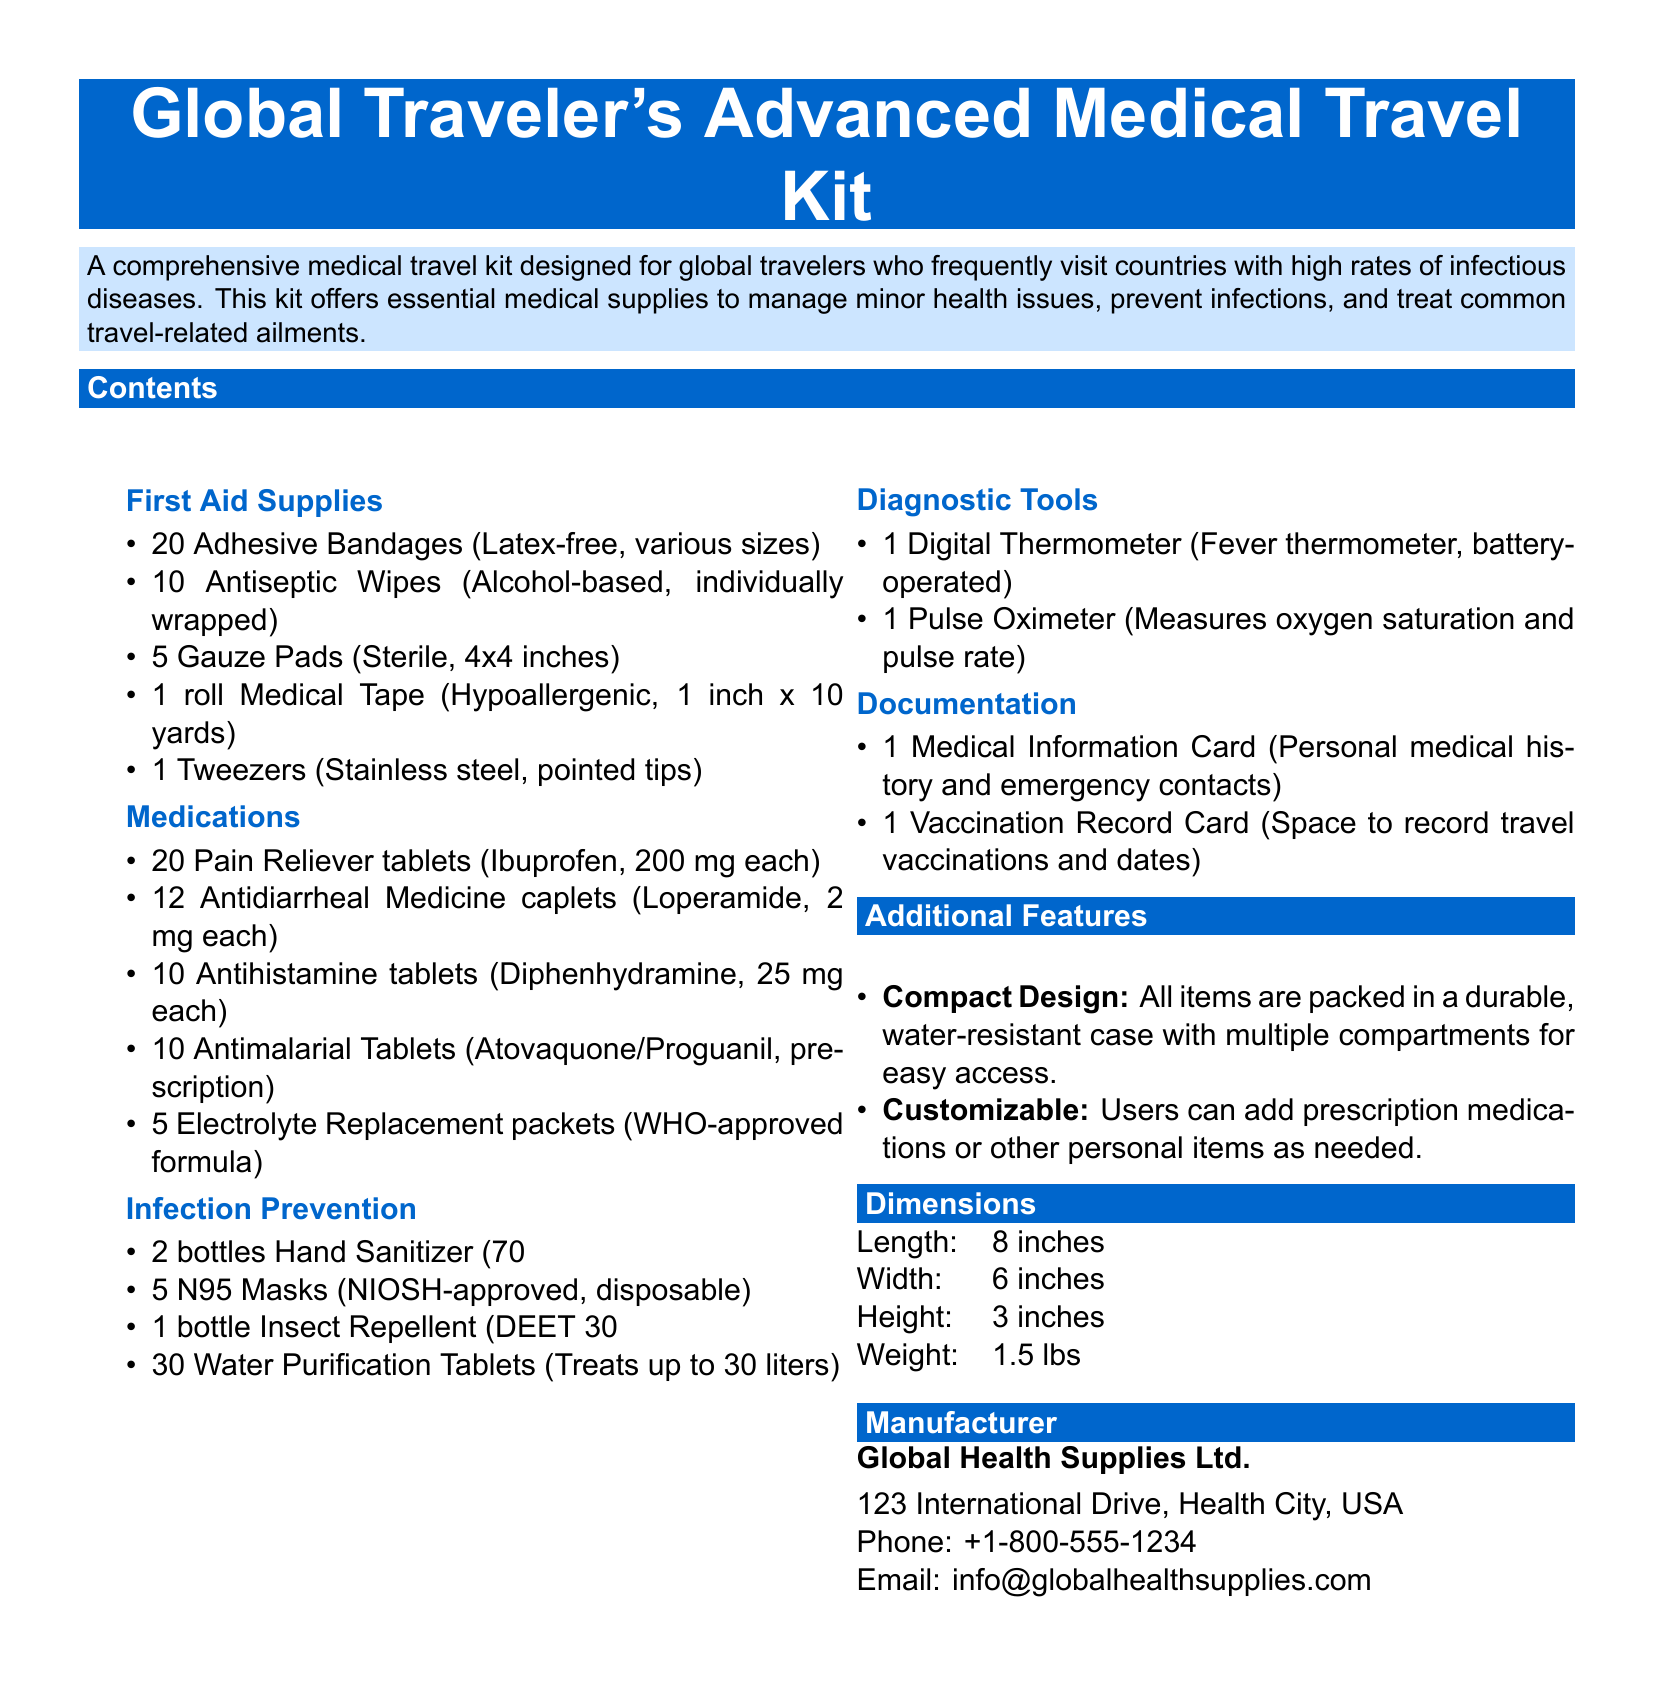What is the weight of the medical travel kit? The weight of the medical travel kit is specified in the dimensions section of the document.
Answer: 1.5 lbs How many Adhesive Bandages are included? The number of Adhesive Bandages is listed under the First Aid Supplies section.
Answer: 20 What types of diagnostic tools are provided? The types of diagnostic tools are mentioned in the Diagnostic Tools section of the document.
Answer: Digital Thermometer, Pulse Oximeter What is the capacity of the Water Purification Tablets? The capacity of the Water Purification Tablets is stated in the Infection Prevention section.
Answer: Treats up to 30 liters Who is the manufacturer of the medical travel kit? The manufacturer information is found at the end of the document.
Answer: Global Health Supplies Ltd How many Antimalarial Tablets are included in the kit? The number of Antimalarial Tablets is indicated in the Medications section.
Answer: 10 What feature allows for personalization of the kit? The customizable feature is mentioned in the Additional Features section of the document.
Answer: Customizable What is the alcohol percentage in the Hand Sanitizer? The alcohol percentage in the Hand Sanitizer is provided under the Infection Prevention section of the kit contents.
Answer: 70% Which section mentions the Medical Information Card? The Medical Information Card is listed in the Documentation section of the document.
Answer: Documentation 